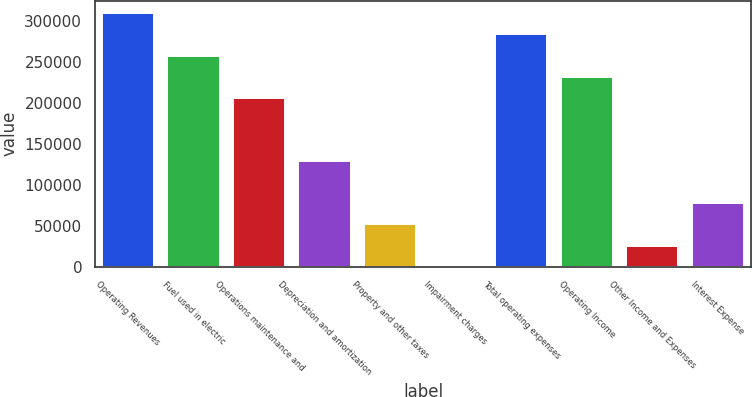Convert chart to OTSL. <chart><loc_0><loc_0><loc_500><loc_500><bar_chart><fcel>Operating Revenues<fcel>Fuel used in electric<fcel>Operations maintenance and<fcel>Depreciation and amortization<fcel>Property and other taxes<fcel>Impairment charges<fcel>Total operating expenses<fcel>Operating Income<fcel>Other Income and Expenses<fcel>Interest Expense<nl><fcel>309032<fcel>257529<fcel>206026<fcel>128772<fcel>51518.6<fcel>16<fcel>283280<fcel>231778<fcel>25767.3<fcel>77269.9<nl></chart> 